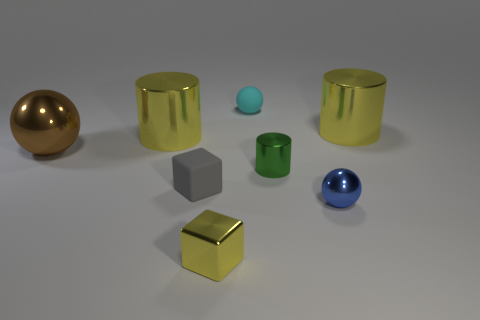Are there any small blue rubber cylinders? no 